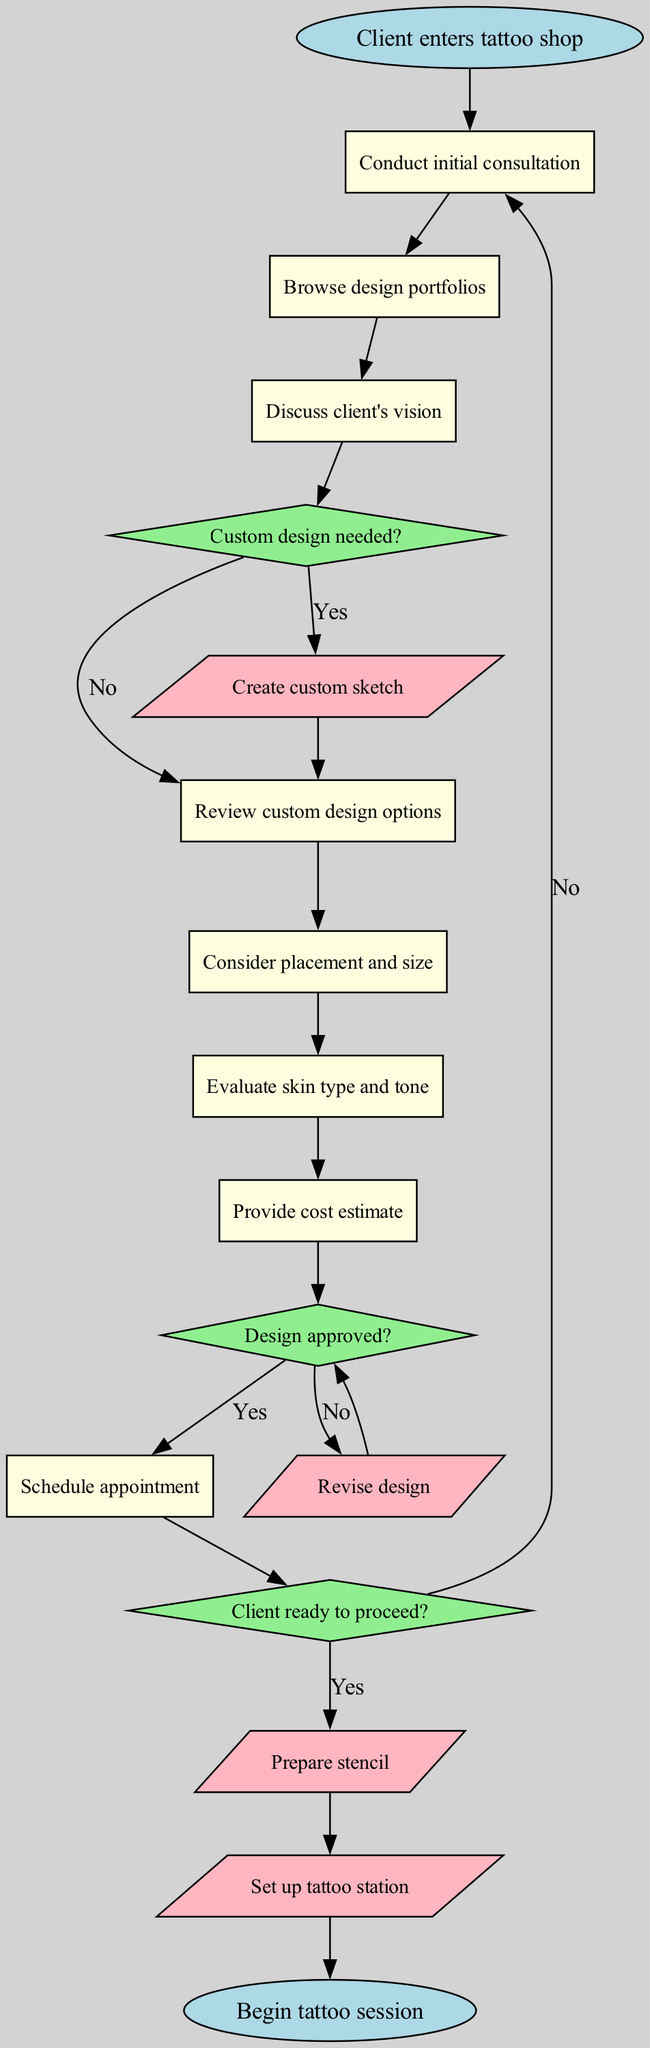What is the first process in the diagram? The first process after the start node is "Conduct initial consultation." This is identified as the first rectangle connected directly to the 'start' node.
Answer: Conduct initial consultation How many decision nodes are present in the diagram? There are three decision nodes, which are the diamond-shaped nodes that require a Yes or No response. They are labeled as "Custom design needed?", "Design approved?", and "Client ready to proceed?"
Answer: 3 What happens if the design is not approved? If the design is not approved (indicated by a "No" from the "Design approved?" decision node), the process moves to the "Revise design" action node and then back to the "Design approved?" decision.
Answer: Revise design Which process node follows after discussing the client's vision? After "Discuss client's vision", the next process node is "Review custom design options". This is established by tracing the flow from the second process to the third process sequentially.
Answer: Review custom design options What is the final action before ending the flowchart? The final action before reaching the end node is "Set up tattoo station". This occurs after the "Prepare stencil" action node and leads directly to the end of the process.
Answer: Set up tattoo station What is the end of the flowchart? The flowchart concludes with "Begin tattoo session," which is the last node in the process flow. This marks the end point of the tattoo design selection process.
Answer: Begin tattoo session What is indicated if a custom design is not needed? If a custom design is not needed, the process flows directly to "Review custom design options". This is the alternative path when the decision is "No" from the "Custom design needed?" node.
Answer: Review custom design options How many processes are there in total? There are eight process nodes present in the diagram, which include all the rectangles representing steps in the tattoo design selection process.
Answer: 8 